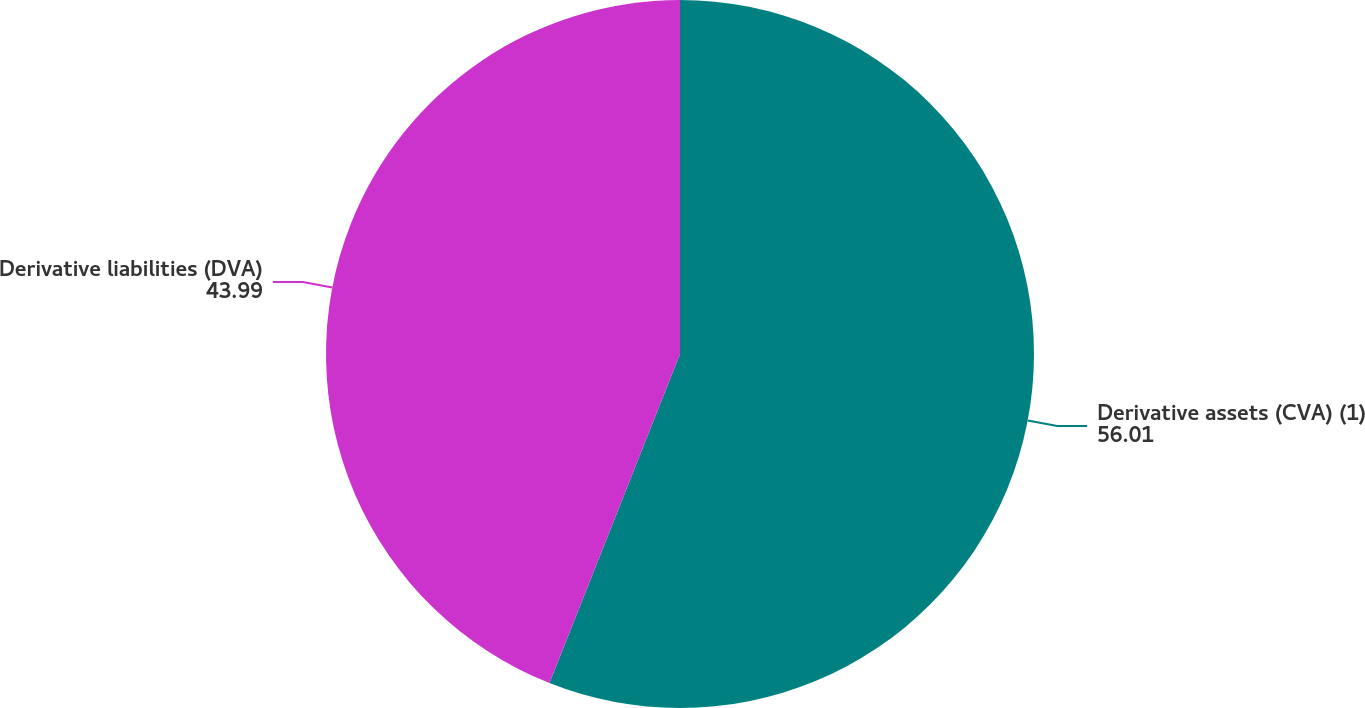Convert chart. <chart><loc_0><loc_0><loc_500><loc_500><pie_chart><fcel>Derivative assets (CVA) (1)<fcel>Derivative liabilities (DVA)<nl><fcel>56.01%<fcel>43.99%<nl></chart> 